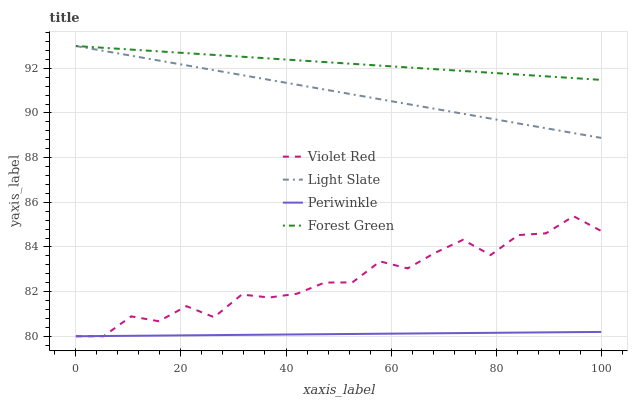Does Periwinkle have the minimum area under the curve?
Answer yes or no. Yes. Does Forest Green have the maximum area under the curve?
Answer yes or no. Yes. Does Violet Red have the minimum area under the curve?
Answer yes or no. No. Does Violet Red have the maximum area under the curve?
Answer yes or no. No. Is Light Slate the smoothest?
Answer yes or no. Yes. Is Violet Red the roughest?
Answer yes or no. Yes. Is Periwinkle the smoothest?
Answer yes or no. No. Is Periwinkle the roughest?
Answer yes or no. No. Does Forest Green have the lowest value?
Answer yes or no. No. Does Violet Red have the highest value?
Answer yes or no. No. Is Violet Red less than Light Slate?
Answer yes or no. Yes. Is Forest Green greater than Violet Red?
Answer yes or no. Yes. Does Violet Red intersect Light Slate?
Answer yes or no. No. 